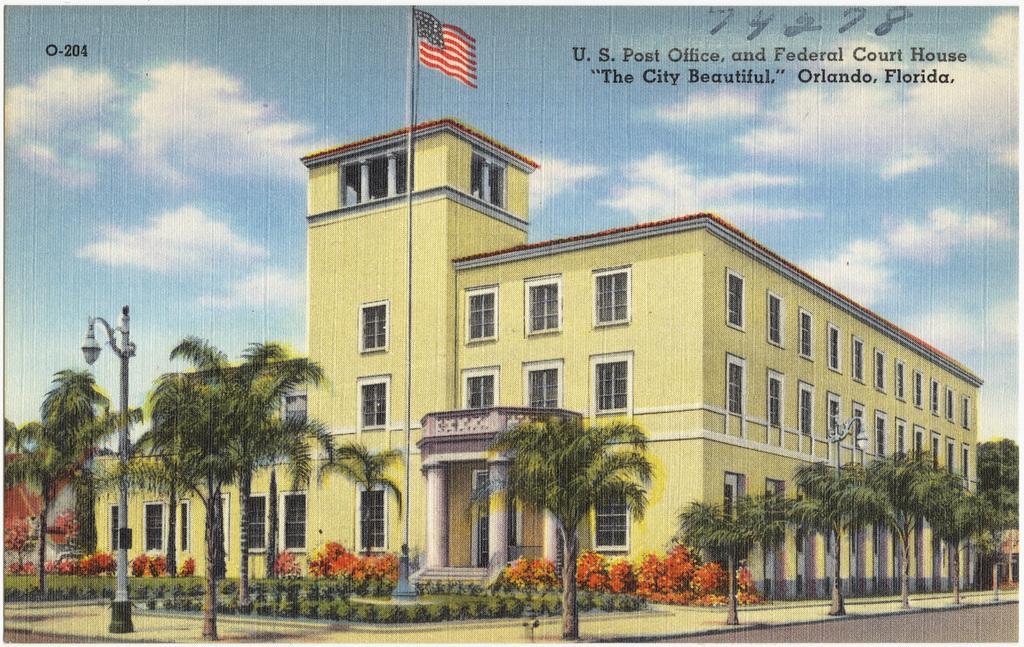Please provide a concise description of this image. In the picture we can see a photograph with a building on it, we can see some windows and pillars and near to it, we can see some plants and pole with a flag and we can also see a tree and in the background we can see a sky with clouds. 